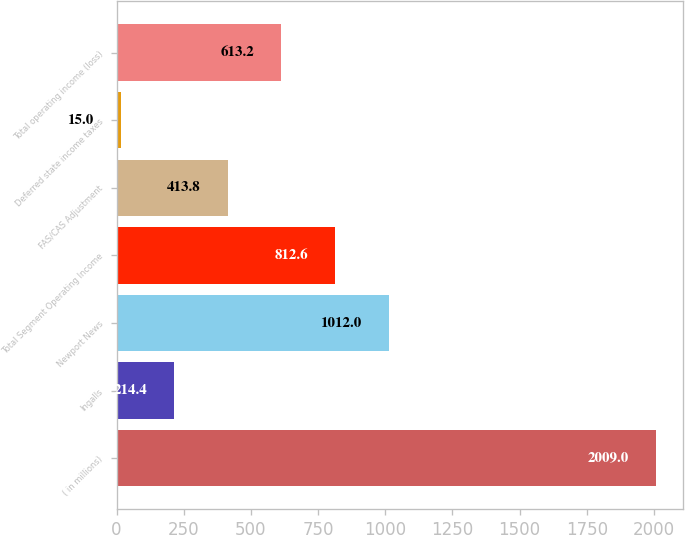<chart> <loc_0><loc_0><loc_500><loc_500><bar_chart><fcel>( in millions)<fcel>Ingalls<fcel>Newport News<fcel>Total Segment Operating Income<fcel>FAS/CAS Adjustment<fcel>Deferred state income taxes<fcel>Total operating income (loss)<nl><fcel>2009<fcel>214.4<fcel>1012<fcel>812.6<fcel>413.8<fcel>15<fcel>613.2<nl></chart> 